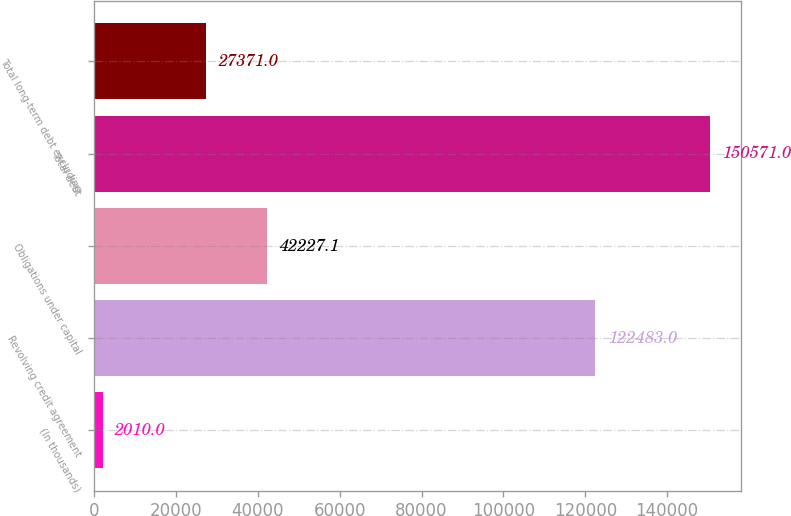<chart> <loc_0><loc_0><loc_500><loc_500><bar_chart><fcel>(In thousands)<fcel>Revolving credit agreement<fcel>Obligations under capital<fcel>Total debt<fcel>Total long-term debt excluding<nl><fcel>2010<fcel>122483<fcel>42227.1<fcel>150571<fcel>27371<nl></chart> 